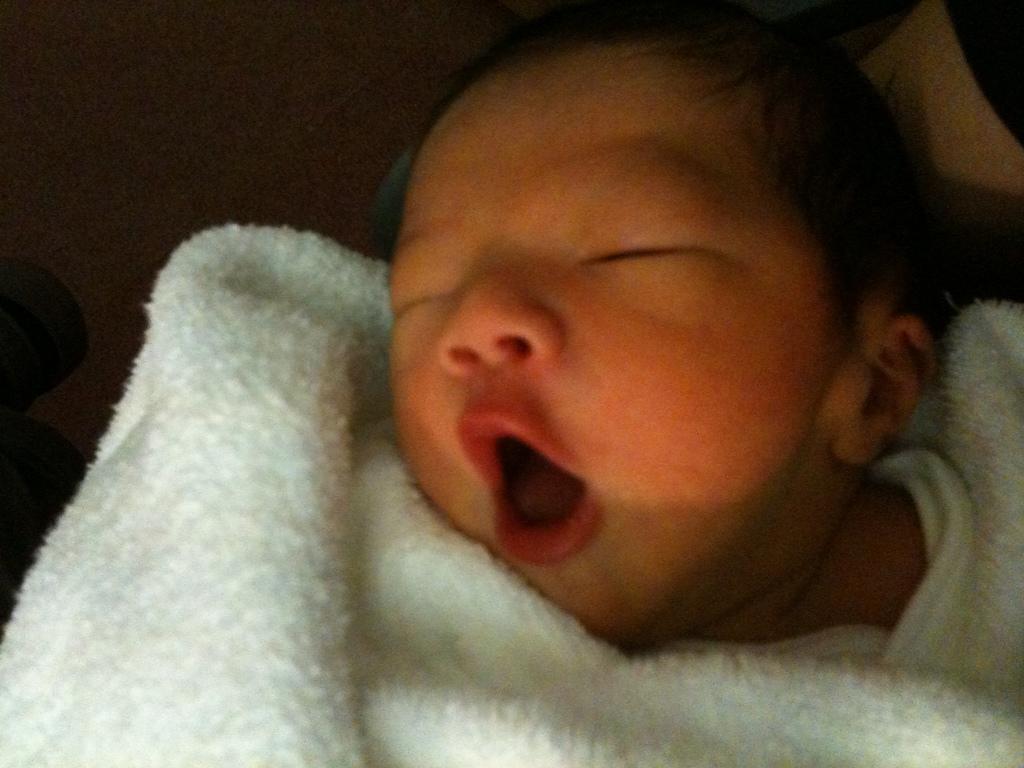Could you give a brief overview of what you see in this image? In this image I can see the baby is sleeping. On the baby I can see the white color blanket. 